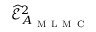Convert formula to latex. <formula><loc_0><loc_0><loc_500><loc_500>\widehat { \mathcal { E } } _ { A _ { M L M C } } ^ { 2 }</formula> 